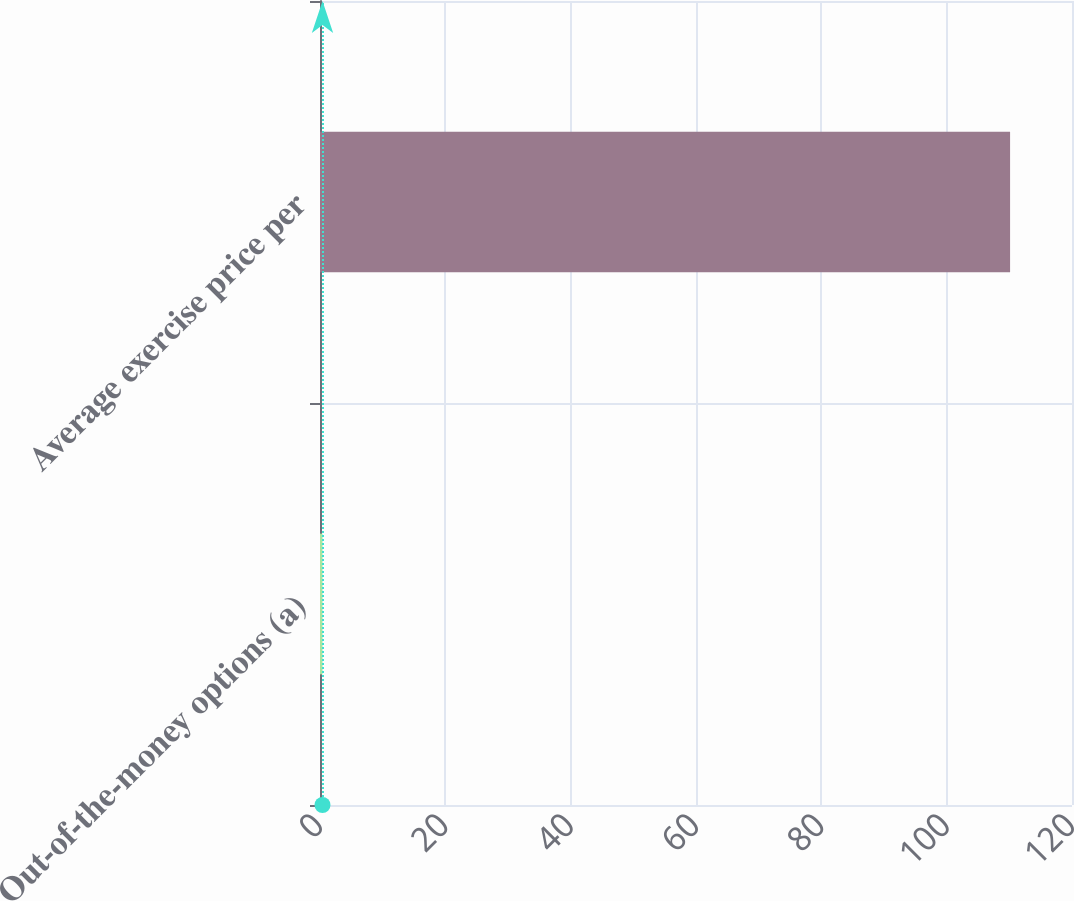Convert chart to OTSL. <chart><loc_0><loc_0><loc_500><loc_500><bar_chart><fcel>Out-of-the-money options (a)<fcel>Average exercise price per<nl><fcel>0.4<fcel>110.12<nl></chart> 